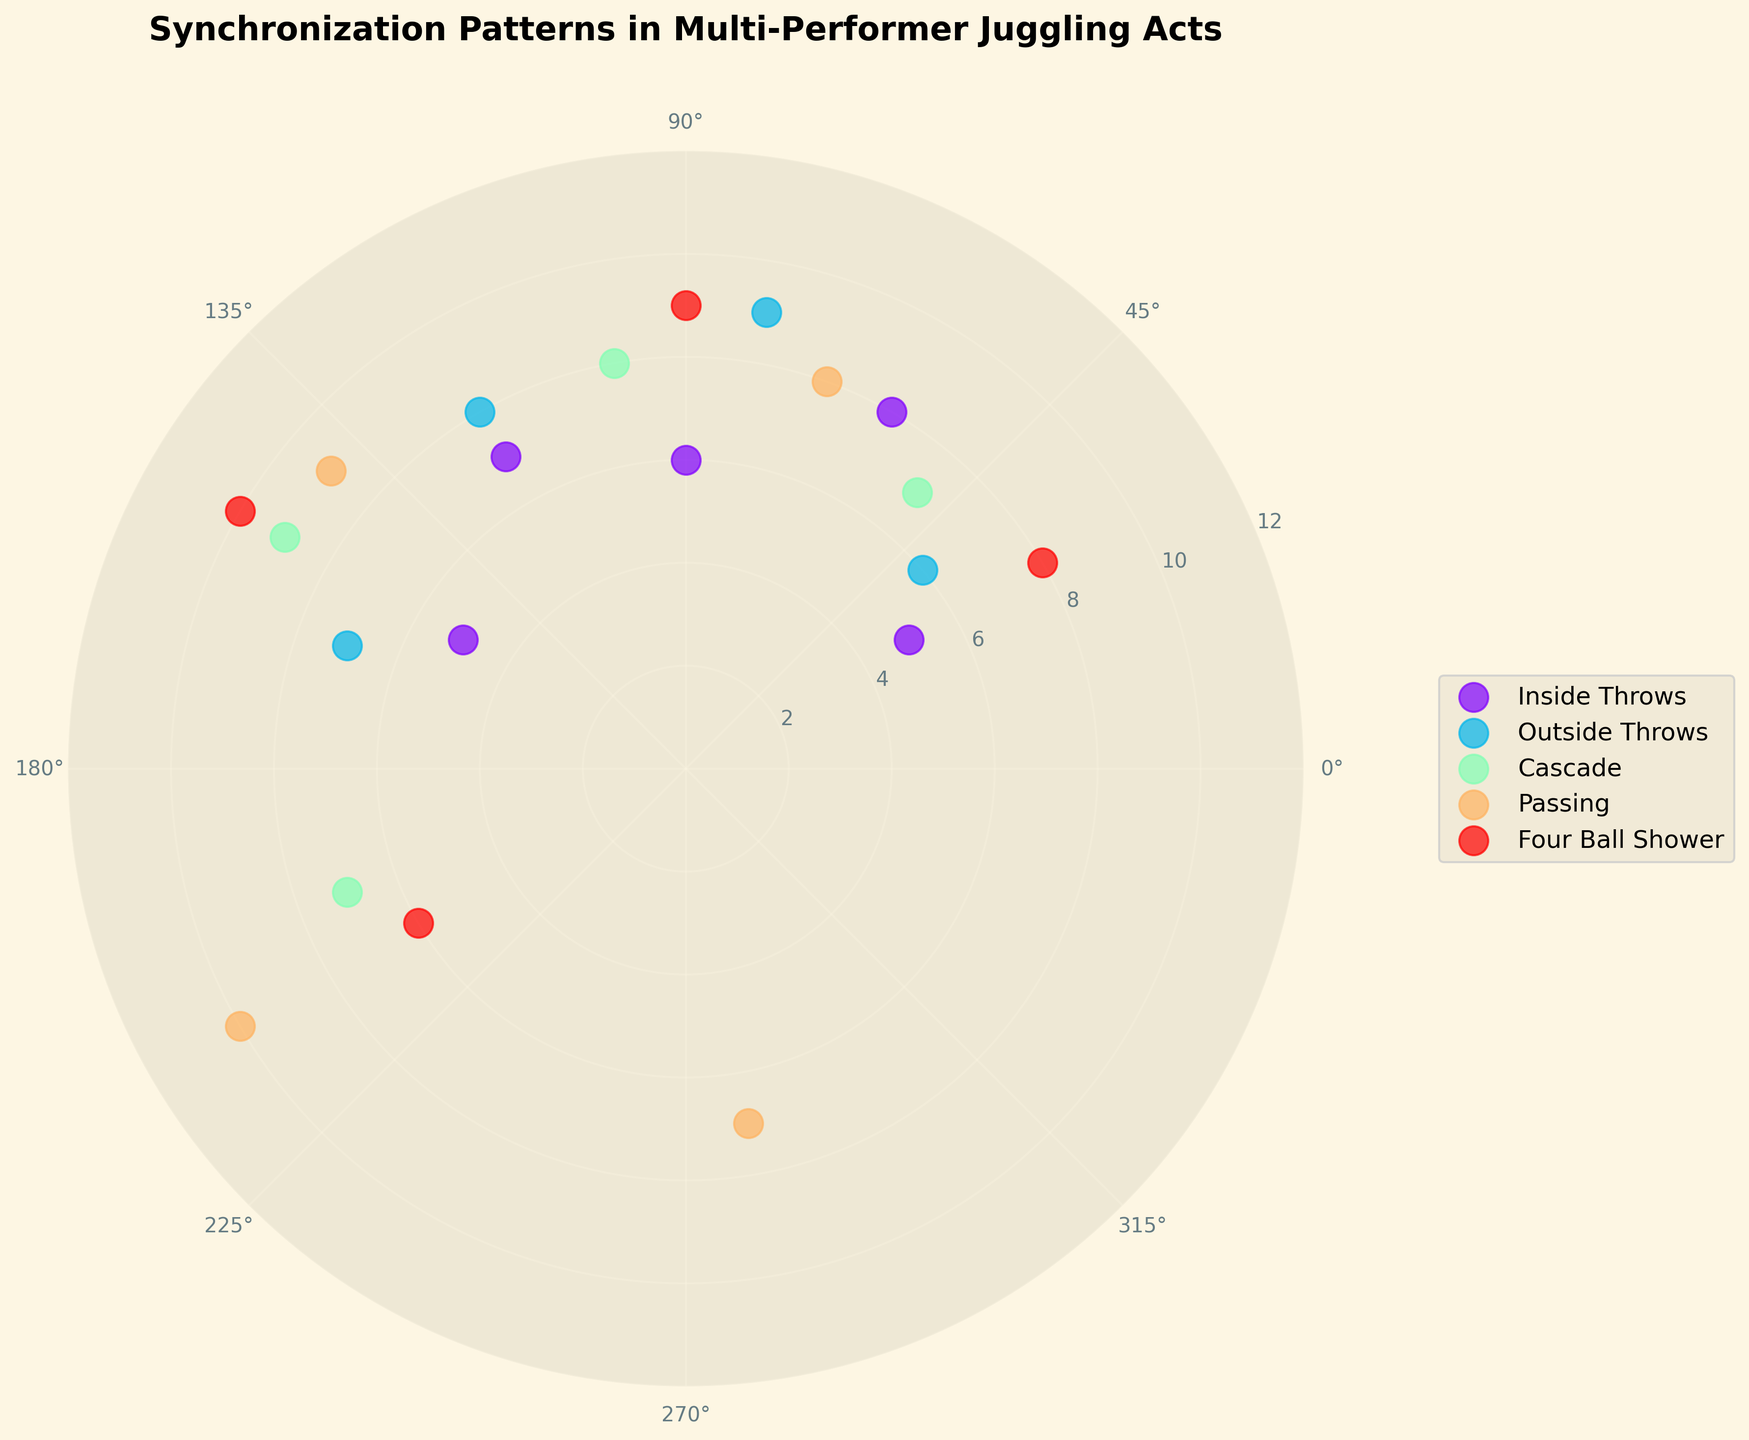What is the title of the chart? The title is usually at the top of the chart and provides a concise description of its content.
Answer: Synchronization Patterns in Multi-Performer Juggling Acts How many different juggling patterns are displayed? Each pattern is represented by a different color and label in the legend. Simply count the distinct patterns listed in the legend.
Answer: Five Which performers execute the pattern called "Cascade"? Each pattern is labeled with its performing pair. Check the legend to find the "Cascade" pattern and then locate the label indicating the performers.
Answer: Eve and Frank What is the largest radial coordinate value, and which pattern does it correspond to? Observe the outermost data points in the radial direction and note their labels to find the highest radial coordinate value and its corresponding pattern.
Answer: 10, Passing How many data points are there for the "Inside Throws" pattern? Count all the scatter points associated with the "Inside Throws" color and label present on the plot.
Answer: Five Which pattern appears at 90 degrees angular coordinate? Identify the data point located at a 90-degree angle from the center and check its label.
Answer: Four Ball Shower Are there any patterns with data points at exactly 180 degrees? If yes, which one(s)? Inspect the plot to find any data points aligned exactly with the 180-degree mark and note their corresponding pattern.
Answer: None Which pattern has the most consistent radial coordinate values? Consistent values will appear as data points uniformly distant from the center. Observe which pattern has the least variation in distance from the center.
Answer: Inside Throws What is the average radial coordinate value for "Four Ball Shower"? Add up all radial coordinate values for the "Four Ball Shower" pattern and divide by the number of data points.
Answer: (8 + 9 + 10 + 6) / 4 = 33 / 4 = 8.25 Compare the radial ranges of "Outside Throws" and "Passing". Which has a wider range? Calculate the radial coordinate range for both patterns (Max - Min) and compare the two results.
Answer: Outside Throws (9 - 6 = 3), Passing (10 - 7 = 3); Both have the same range (3) 